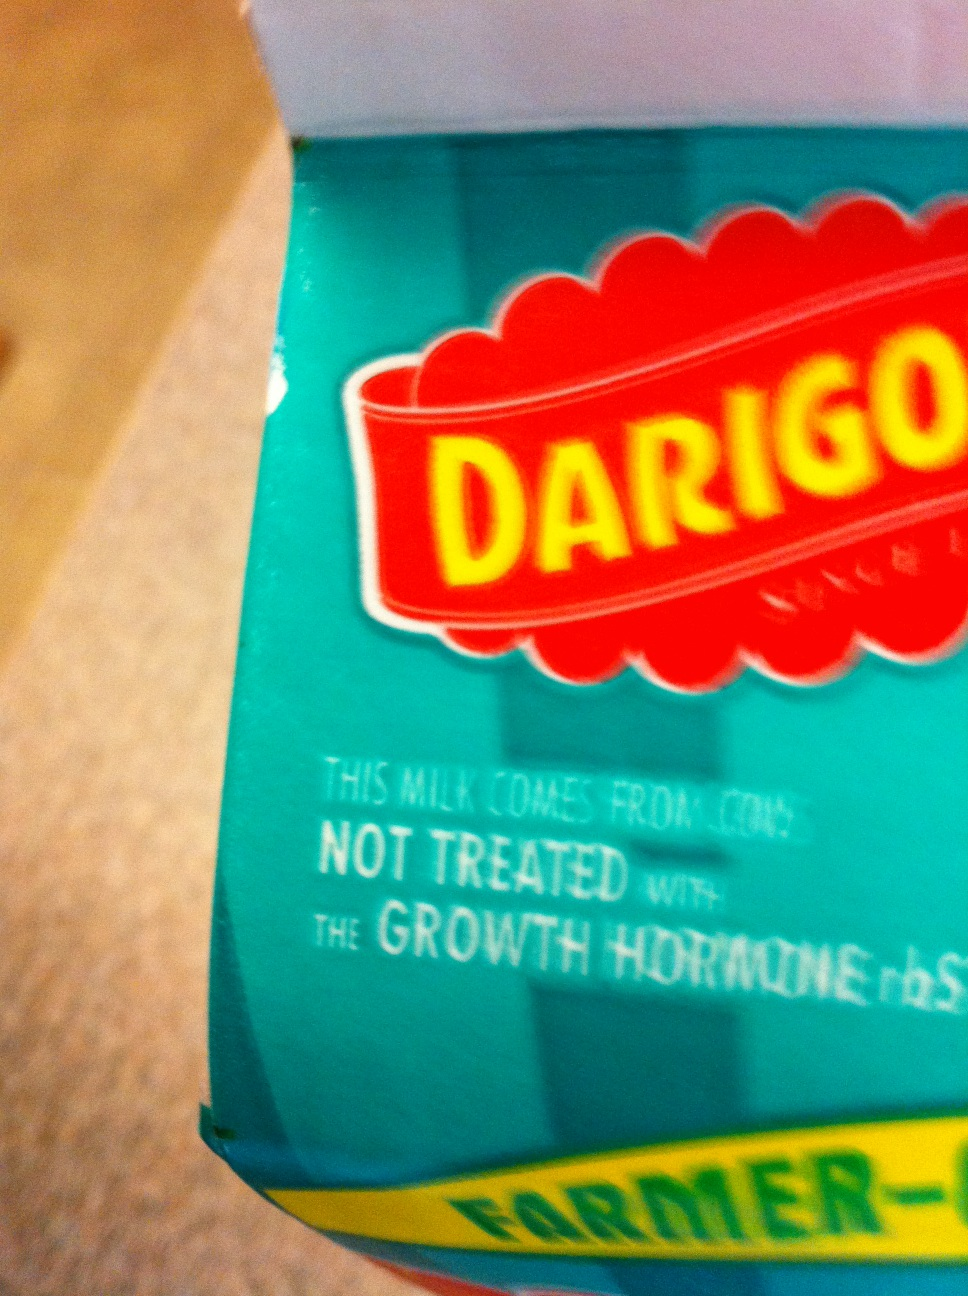I'm looking for the expiration date on this milk. I moved the camera so tell me if this image is better. Unfortunately, I cannot provide assistance in locating the expiration date as the image is blurry and the relevant information is not visible. To help you find the expiration date, ensure the image clearly shows the top or side of the milk carton where such dates are typically printed. 